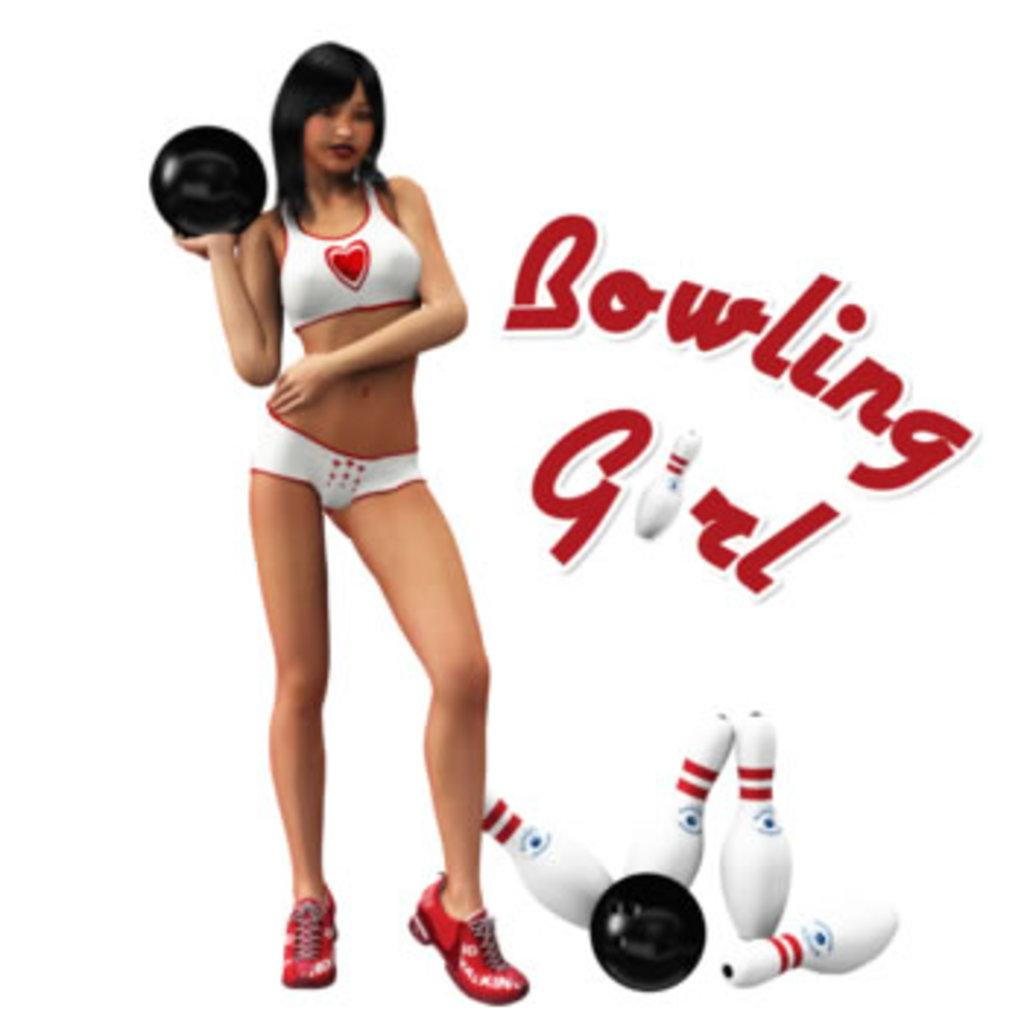<image>
Present a compact description of the photo's key features. Woman holding a ball with the words "Bowling Girl" next to her. 